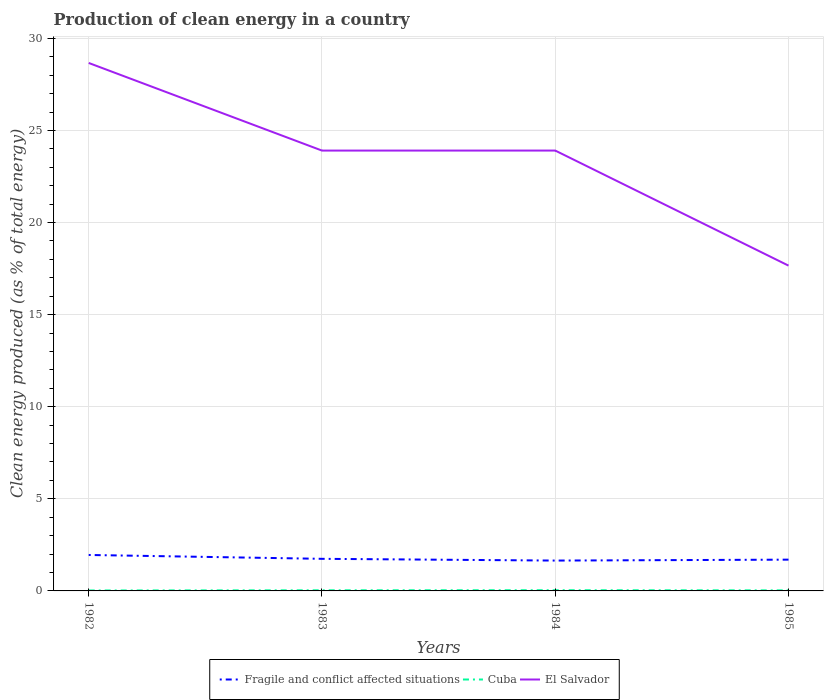How many different coloured lines are there?
Your answer should be very brief. 3. Does the line corresponding to Fragile and conflict affected situations intersect with the line corresponding to Cuba?
Your answer should be compact. No. Is the number of lines equal to the number of legend labels?
Make the answer very short. Yes. Across all years, what is the maximum percentage of clean energy produced in El Salvador?
Keep it short and to the point. 17.66. In which year was the percentage of clean energy produced in Fragile and conflict affected situations maximum?
Give a very brief answer. 1984. What is the total percentage of clean energy produced in Cuba in the graph?
Provide a short and direct response. 0.01. What is the difference between the highest and the second highest percentage of clean energy produced in Cuba?
Give a very brief answer. 0.01. What is the difference between the highest and the lowest percentage of clean energy produced in El Salvador?
Offer a very short reply. 3. Is the percentage of clean energy produced in El Salvador strictly greater than the percentage of clean energy produced in Fragile and conflict affected situations over the years?
Your response must be concise. No. What is the difference between two consecutive major ticks on the Y-axis?
Ensure brevity in your answer.  5. Are the values on the major ticks of Y-axis written in scientific E-notation?
Provide a succinct answer. No. Does the graph contain any zero values?
Offer a terse response. No. Does the graph contain grids?
Your answer should be compact. Yes. Where does the legend appear in the graph?
Ensure brevity in your answer.  Bottom center. How many legend labels are there?
Offer a terse response. 3. How are the legend labels stacked?
Provide a short and direct response. Horizontal. What is the title of the graph?
Your answer should be very brief. Production of clean energy in a country. Does "Palau" appear as one of the legend labels in the graph?
Offer a terse response. No. What is the label or title of the X-axis?
Make the answer very short. Years. What is the label or title of the Y-axis?
Provide a short and direct response. Clean energy produced (as % of total energy). What is the Clean energy produced (as % of total energy) of Fragile and conflict affected situations in 1982?
Provide a short and direct response. 1.95. What is the Clean energy produced (as % of total energy) of Cuba in 1982?
Offer a very short reply. 0.02. What is the Clean energy produced (as % of total energy) of El Salvador in 1982?
Provide a succinct answer. 28.66. What is the Clean energy produced (as % of total energy) of Fragile and conflict affected situations in 1983?
Your response must be concise. 1.74. What is the Clean energy produced (as % of total energy) of Cuba in 1983?
Make the answer very short. 0.03. What is the Clean energy produced (as % of total energy) of El Salvador in 1983?
Offer a terse response. 23.91. What is the Clean energy produced (as % of total energy) in Fragile and conflict affected situations in 1984?
Ensure brevity in your answer.  1.65. What is the Clean energy produced (as % of total energy) in Cuba in 1984?
Provide a short and direct response. 0.04. What is the Clean energy produced (as % of total energy) of El Salvador in 1984?
Your response must be concise. 23.91. What is the Clean energy produced (as % of total energy) of Fragile and conflict affected situations in 1985?
Offer a very short reply. 1.7. What is the Clean energy produced (as % of total energy) in Cuba in 1985?
Your answer should be compact. 0.03. What is the Clean energy produced (as % of total energy) of El Salvador in 1985?
Give a very brief answer. 17.66. Across all years, what is the maximum Clean energy produced (as % of total energy) of Fragile and conflict affected situations?
Offer a very short reply. 1.95. Across all years, what is the maximum Clean energy produced (as % of total energy) in Cuba?
Offer a terse response. 0.04. Across all years, what is the maximum Clean energy produced (as % of total energy) in El Salvador?
Offer a terse response. 28.66. Across all years, what is the minimum Clean energy produced (as % of total energy) in Fragile and conflict affected situations?
Your answer should be very brief. 1.65. Across all years, what is the minimum Clean energy produced (as % of total energy) of Cuba?
Ensure brevity in your answer.  0.02. Across all years, what is the minimum Clean energy produced (as % of total energy) of El Salvador?
Offer a very short reply. 17.66. What is the total Clean energy produced (as % of total energy) of Fragile and conflict affected situations in the graph?
Offer a very short reply. 7.04. What is the total Clean energy produced (as % of total energy) of Cuba in the graph?
Keep it short and to the point. 0.13. What is the total Clean energy produced (as % of total energy) of El Salvador in the graph?
Provide a succinct answer. 94.14. What is the difference between the Clean energy produced (as % of total energy) of Fragile and conflict affected situations in 1982 and that in 1983?
Provide a succinct answer. 0.21. What is the difference between the Clean energy produced (as % of total energy) in Cuba in 1982 and that in 1983?
Ensure brevity in your answer.  -0.01. What is the difference between the Clean energy produced (as % of total energy) in El Salvador in 1982 and that in 1983?
Make the answer very short. 4.76. What is the difference between the Clean energy produced (as % of total energy) in Fragile and conflict affected situations in 1982 and that in 1984?
Offer a very short reply. 0.3. What is the difference between the Clean energy produced (as % of total energy) of Cuba in 1982 and that in 1984?
Offer a terse response. -0.01. What is the difference between the Clean energy produced (as % of total energy) in El Salvador in 1982 and that in 1984?
Keep it short and to the point. 4.76. What is the difference between the Clean energy produced (as % of total energy) in Fragile and conflict affected situations in 1982 and that in 1985?
Ensure brevity in your answer.  0.25. What is the difference between the Clean energy produced (as % of total energy) of Cuba in 1982 and that in 1985?
Provide a succinct answer. -0.01. What is the difference between the Clean energy produced (as % of total energy) in El Salvador in 1982 and that in 1985?
Give a very brief answer. 11. What is the difference between the Clean energy produced (as % of total energy) in Fragile and conflict affected situations in 1983 and that in 1984?
Give a very brief answer. 0.1. What is the difference between the Clean energy produced (as % of total energy) of Cuba in 1983 and that in 1984?
Provide a short and direct response. -0. What is the difference between the Clean energy produced (as % of total energy) of El Salvador in 1983 and that in 1984?
Make the answer very short. -0. What is the difference between the Clean energy produced (as % of total energy) in Fragile and conflict affected situations in 1983 and that in 1985?
Keep it short and to the point. 0.04. What is the difference between the Clean energy produced (as % of total energy) of Cuba in 1983 and that in 1985?
Give a very brief answer. 0. What is the difference between the Clean energy produced (as % of total energy) of El Salvador in 1983 and that in 1985?
Keep it short and to the point. 6.25. What is the difference between the Clean energy produced (as % of total energy) of Fragile and conflict affected situations in 1984 and that in 1985?
Your answer should be compact. -0.05. What is the difference between the Clean energy produced (as % of total energy) in Cuba in 1984 and that in 1985?
Provide a short and direct response. 0.01. What is the difference between the Clean energy produced (as % of total energy) in El Salvador in 1984 and that in 1985?
Provide a succinct answer. 6.25. What is the difference between the Clean energy produced (as % of total energy) of Fragile and conflict affected situations in 1982 and the Clean energy produced (as % of total energy) of Cuba in 1983?
Keep it short and to the point. 1.92. What is the difference between the Clean energy produced (as % of total energy) in Fragile and conflict affected situations in 1982 and the Clean energy produced (as % of total energy) in El Salvador in 1983?
Provide a short and direct response. -21.95. What is the difference between the Clean energy produced (as % of total energy) of Cuba in 1982 and the Clean energy produced (as % of total energy) of El Salvador in 1983?
Make the answer very short. -23.88. What is the difference between the Clean energy produced (as % of total energy) in Fragile and conflict affected situations in 1982 and the Clean energy produced (as % of total energy) in Cuba in 1984?
Offer a very short reply. 1.91. What is the difference between the Clean energy produced (as % of total energy) in Fragile and conflict affected situations in 1982 and the Clean energy produced (as % of total energy) in El Salvador in 1984?
Offer a very short reply. -21.96. What is the difference between the Clean energy produced (as % of total energy) of Cuba in 1982 and the Clean energy produced (as % of total energy) of El Salvador in 1984?
Your response must be concise. -23.88. What is the difference between the Clean energy produced (as % of total energy) in Fragile and conflict affected situations in 1982 and the Clean energy produced (as % of total energy) in Cuba in 1985?
Your response must be concise. 1.92. What is the difference between the Clean energy produced (as % of total energy) of Fragile and conflict affected situations in 1982 and the Clean energy produced (as % of total energy) of El Salvador in 1985?
Keep it short and to the point. -15.71. What is the difference between the Clean energy produced (as % of total energy) in Cuba in 1982 and the Clean energy produced (as % of total energy) in El Salvador in 1985?
Make the answer very short. -17.64. What is the difference between the Clean energy produced (as % of total energy) in Fragile and conflict affected situations in 1983 and the Clean energy produced (as % of total energy) in Cuba in 1984?
Your answer should be very brief. 1.7. What is the difference between the Clean energy produced (as % of total energy) in Fragile and conflict affected situations in 1983 and the Clean energy produced (as % of total energy) in El Salvador in 1984?
Provide a short and direct response. -22.16. What is the difference between the Clean energy produced (as % of total energy) in Cuba in 1983 and the Clean energy produced (as % of total energy) in El Salvador in 1984?
Your answer should be compact. -23.87. What is the difference between the Clean energy produced (as % of total energy) of Fragile and conflict affected situations in 1983 and the Clean energy produced (as % of total energy) of Cuba in 1985?
Provide a succinct answer. 1.71. What is the difference between the Clean energy produced (as % of total energy) in Fragile and conflict affected situations in 1983 and the Clean energy produced (as % of total energy) in El Salvador in 1985?
Provide a short and direct response. -15.92. What is the difference between the Clean energy produced (as % of total energy) of Cuba in 1983 and the Clean energy produced (as % of total energy) of El Salvador in 1985?
Ensure brevity in your answer.  -17.63. What is the difference between the Clean energy produced (as % of total energy) in Fragile and conflict affected situations in 1984 and the Clean energy produced (as % of total energy) in Cuba in 1985?
Give a very brief answer. 1.62. What is the difference between the Clean energy produced (as % of total energy) of Fragile and conflict affected situations in 1984 and the Clean energy produced (as % of total energy) of El Salvador in 1985?
Provide a succinct answer. -16.01. What is the difference between the Clean energy produced (as % of total energy) in Cuba in 1984 and the Clean energy produced (as % of total energy) in El Salvador in 1985?
Keep it short and to the point. -17.62. What is the average Clean energy produced (as % of total energy) in Fragile and conflict affected situations per year?
Provide a succinct answer. 1.76. What is the average Clean energy produced (as % of total energy) in Cuba per year?
Your response must be concise. 0.03. What is the average Clean energy produced (as % of total energy) of El Salvador per year?
Offer a very short reply. 23.53. In the year 1982, what is the difference between the Clean energy produced (as % of total energy) of Fragile and conflict affected situations and Clean energy produced (as % of total energy) of Cuba?
Offer a very short reply. 1.93. In the year 1982, what is the difference between the Clean energy produced (as % of total energy) of Fragile and conflict affected situations and Clean energy produced (as % of total energy) of El Salvador?
Offer a very short reply. -26.71. In the year 1982, what is the difference between the Clean energy produced (as % of total energy) of Cuba and Clean energy produced (as % of total energy) of El Salvador?
Give a very brief answer. -28.64. In the year 1983, what is the difference between the Clean energy produced (as % of total energy) in Fragile and conflict affected situations and Clean energy produced (as % of total energy) in Cuba?
Provide a short and direct response. 1.71. In the year 1983, what is the difference between the Clean energy produced (as % of total energy) of Fragile and conflict affected situations and Clean energy produced (as % of total energy) of El Salvador?
Ensure brevity in your answer.  -22.16. In the year 1983, what is the difference between the Clean energy produced (as % of total energy) of Cuba and Clean energy produced (as % of total energy) of El Salvador?
Ensure brevity in your answer.  -23.87. In the year 1984, what is the difference between the Clean energy produced (as % of total energy) in Fragile and conflict affected situations and Clean energy produced (as % of total energy) in Cuba?
Your answer should be compact. 1.61. In the year 1984, what is the difference between the Clean energy produced (as % of total energy) in Fragile and conflict affected situations and Clean energy produced (as % of total energy) in El Salvador?
Ensure brevity in your answer.  -22.26. In the year 1984, what is the difference between the Clean energy produced (as % of total energy) in Cuba and Clean energy produced (as % of total energy) in El Salvador?
Keep it short and to the point. -23.87. In the year 1985, what is the difference between the Clean energy produced (as % of total energy) of Fragile and conflict affected situations and Clean energy produced (as % of total energy) of Cuba?
Provide a short and direct response. 1.67. In the year 1985, what is the difference between the Clean energy produced (as % of total energy) of Fragile and conflict affected situations and Clean energy produced (as % of total energy) of El Salvador?
Offer a very short reply. -15.96. In the year 1985, what is the difference between the Clean energy produced (as % of total energy) in Cuba and Clean energy produced (as % of total energy) in El Salvador?
Keep it short and to the point. -17.63. What is the ratio of the Clean energy produced (as % of total energy) of Fragile and conflict affected situations in 1982 to that in 1983?
Keep it short and to the point. 1.12. What is the ratio of the Clean energy produced (as % of total energy) in Cuba in 1982 to that in 1983?
Offer a terse response. 0.72. What is the ratio of the Clean energy produced (as % of total energy) in El Salvador in 1982 to that in 1983?
Give a very brief answer. 1.2. What is the ratio of the Clean energy produced (as % of total energy) of Fragile and conflict affected situations in 1982 to that in 1984?
Provide a short and direct response. 1.18. What is the ratio of the Clean energy produced (as % of total energy) in Cuba in 1982 to that in 1984?
Your answer should be compact. 0.63. What is the ratio of the Clean energy produced (as % of total energy) of El Salvador in 1982 to that in 1984?
Your response must be concise. 1.2. What is the ratio of the Clean energy produced (as % of total energy) in Fragile and conflict affected situations in 1982 to that in 1985?
Offer a terse response. 1.15. What is the ratio of the Clean energy produced (as % of total energy) in Cuba in 1982 to that in 1985?
Your response must be concise. 0.82. What is the ratio of the Clean energy produced (as % of total energy) of El Salvador in 1982 to that in 1985?
Make the answer very short. 1.62. What is the ratio of the Clean energy produced (as % of total energy) in Fragile and conflict affected situations in 1983 to that in 1984?
Provide a short and direct response. 1.06. What is the ratio of the Clean energy produced (as % of total energy) in Cuba in 1983 to that in 1984?
Give a very brief answer. 0.88. What is the ratio of the Clean energy produced (as % of total energy) in Fragile and conflict affected situations in 1983 to that in 1985?
Your answer should be very brief. 1.03. What is the ratio of the Clean energy produced (as % of total energy) of Cuba in 1983 to that in 1985?
Make the answer very short. 1.13. What is the ratio of the Clean energy produced (as % of total energy) of El Salvador in 1983 to that in 1985?
Give a very brief answer. 1.35. What is the ratio of the Clean energy produced (as % of total energy) of Fragile and conflict affected situations in 1984 to that in 1985?
Your answer should be compact. 0.97. What is the ratio of the Clean energy produced (as % of total energy) of Cuba in 1984 to that in 1985?
Ensure brevity in your answer.  1.29. What is the ratio of the Clean energy produced (as % of total energy) of El Salvador in 1984 to that in 1985?
Give a very brief answer. 1.35. What is the difference between the highest and the second highest Clean energy produced (as % of total energy) of Fragile and conflict affected situations?
Ensure brevity in your answer.  0.21. What is the difference between the highest and the second highest Clean energy produced (as % of total energy) in Cuba?
Keep it short and to the point. 0. What is the difference between the highest and the second highest Clean energy produced (as % of total energy) in El Salvador?
Your answer should be compact. 4.76. What is the difference between the highest and the lowest Clean energy produced (as % of total energy) of Fragile and conflict affected situations?
Your answer should be very brief. 0.3. What is the difference between the highest and the lowest Clean energy produced (as % of total energy) in Cuba?
Ensure brevity in your answer.  0.01. What is the difference between the highest and the lowest Clean energy produced (as % of total energy) of El Salvador?
Offer a very short reply. 11. 